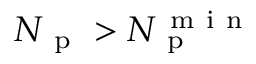<formula> <loc_0><loc_0><loc_500><loc_500>N _ { p } > N _ { p } ^ { m i n }</formula> 